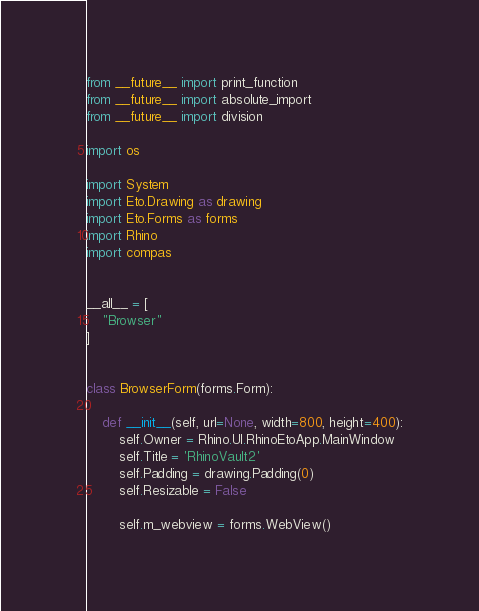<code> <loc_0><loc_0><loc_500><loc_500><_Python_>from __future__ import print_function
from __future__ import absolute_import
from __future__ import division

import os

import System
import Eto.Drawing as drawing
import Eto.Forms as forms
import Rhino
import compas


__all__ = [
    "Browser"
]


class BrowserForm(forms.Form):

    def __init__(self, url=None, width=800, height=400):
        self.Owner = Rhino.UI.RhinoEtoApp.MainWindow
        self.Title = 'RhinoVault2'
        self.Padding = drawing.Padding(0)
        self.Resizable = False

        self.m_webview = forms.WebView()</code> 